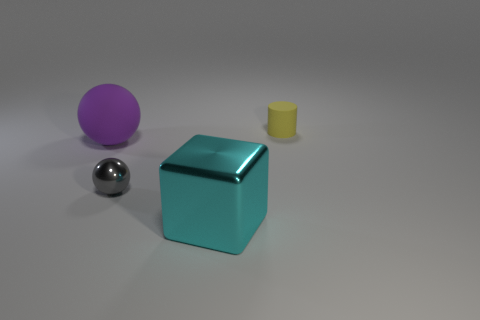How big is the matte object in front of the tiny yellow thing behind the metallic ball?
Your answer should be compact. Large. There is a big purple matte thing; how many large cyan metal blocks are to the left of it?
Give a very brief answer. 0. How big is the yellow rubber cylinder?
Make the answer very short. Small. Do the small object that is left of the big cyan block and the tiny object that is on the right side of the tiny gray metal object have the same material?
Provide a succinct answer. No. Are there any metal blocks of the same color as the large rubber thing?
Your response must be concise. No. The cylinder that is the same size as the gray ball is what color?
Provide a succinct answer. Yellow. There is a tiny thing in front of the big purple matte sphere; is it the same color as the small rubber cylinder?
Ensure brevity in your answer.  No. Are there any cyan blocks that have the same material as the purple object?
Provide a succinct answer. No. Are there fewer cylinders left of the cyan metallic object than yellow spheres?
Make the answer very short. No. Do the gray object that is right of the purple rubber object and the small yellow cylinder have the same size?
Your answer should be compact. Yes. 